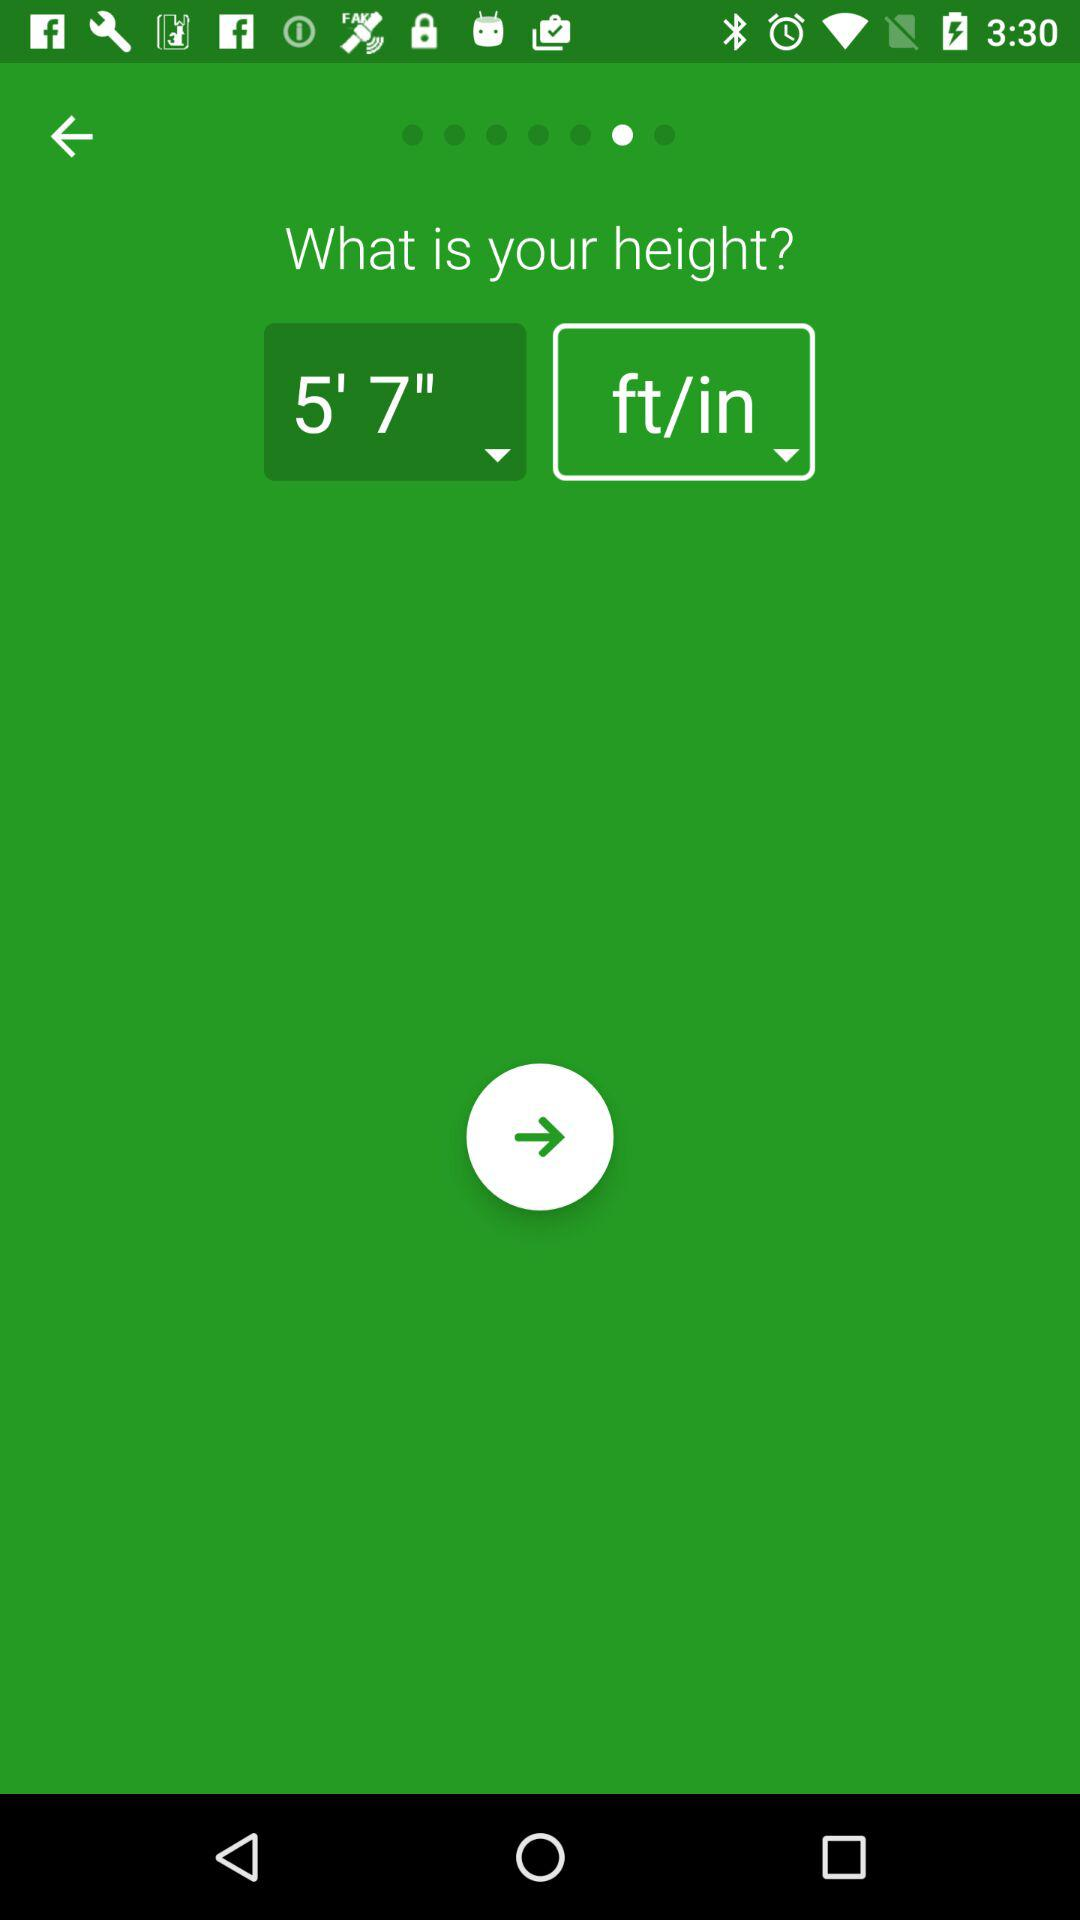What is the measuring unit of height? The measuring unit of height is feet per inch. 